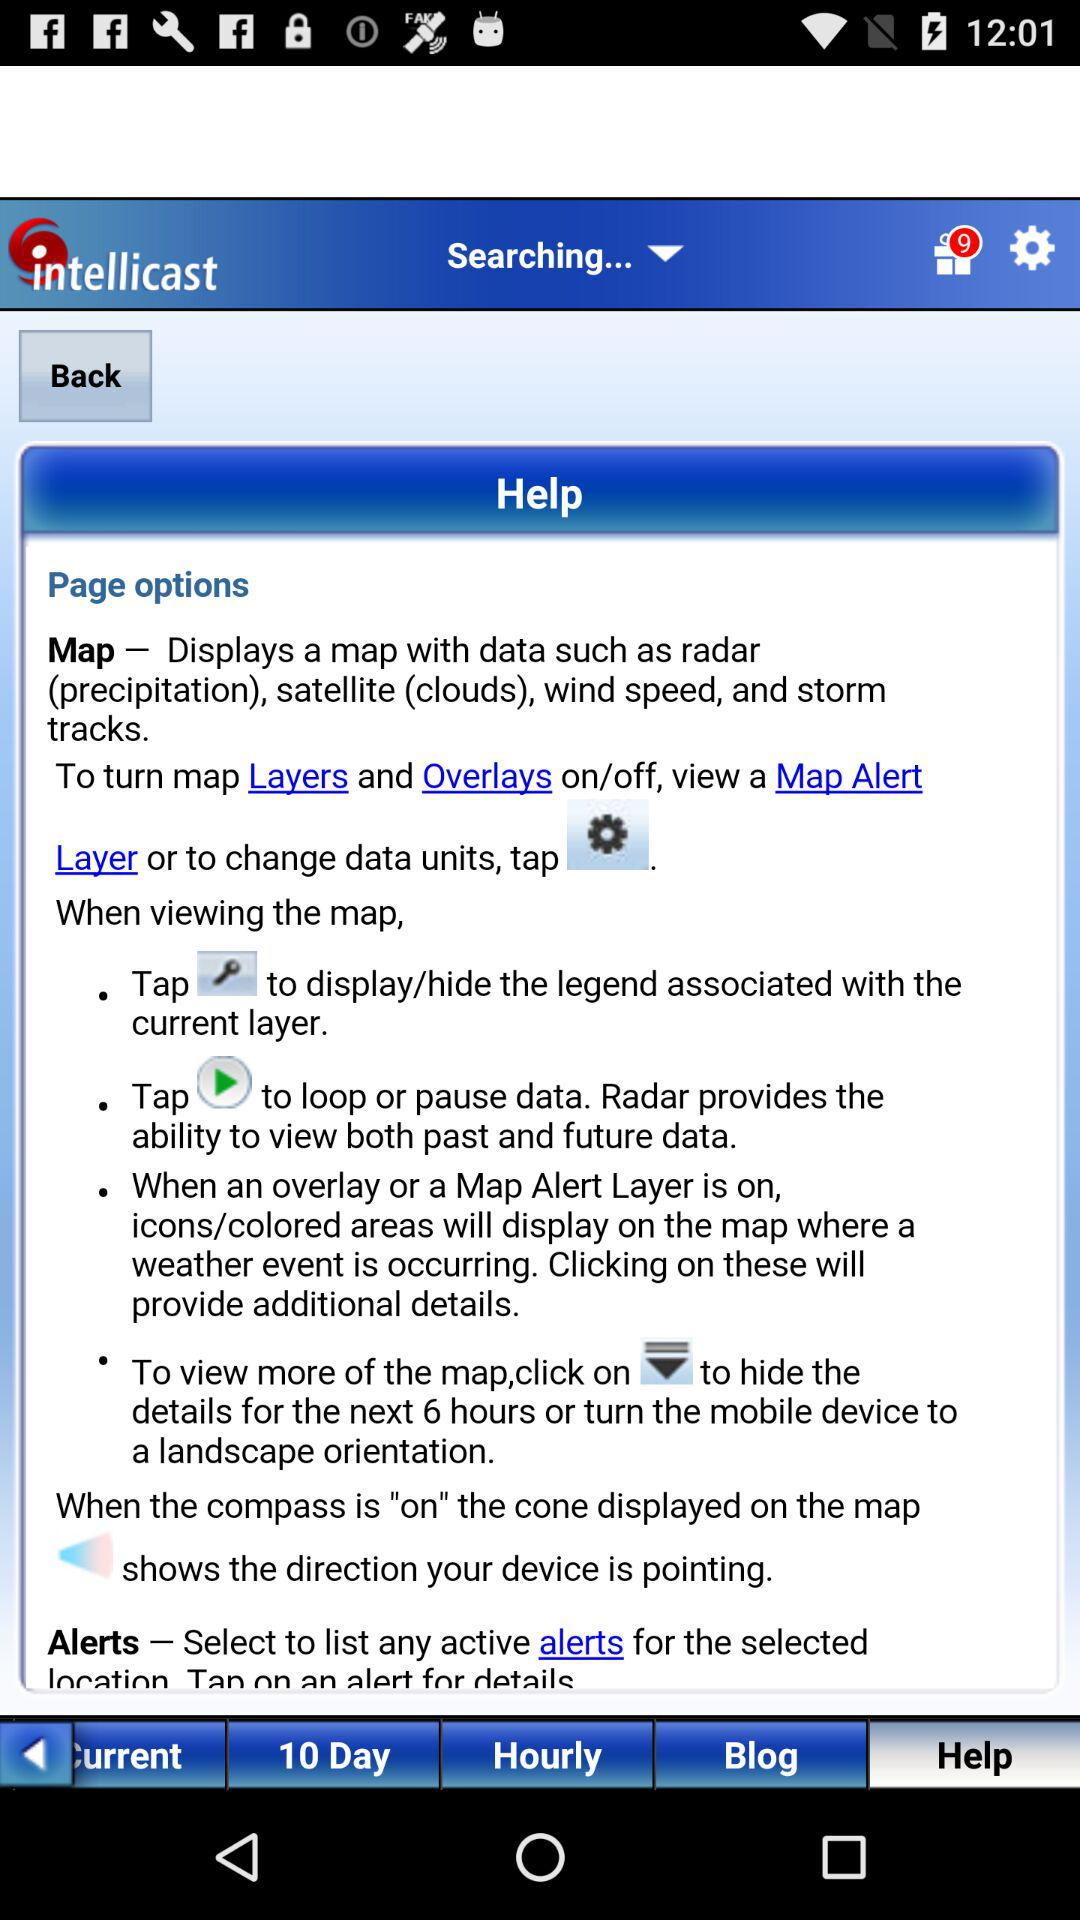How many notifications are there in the gift option? There are 9 notifications. 